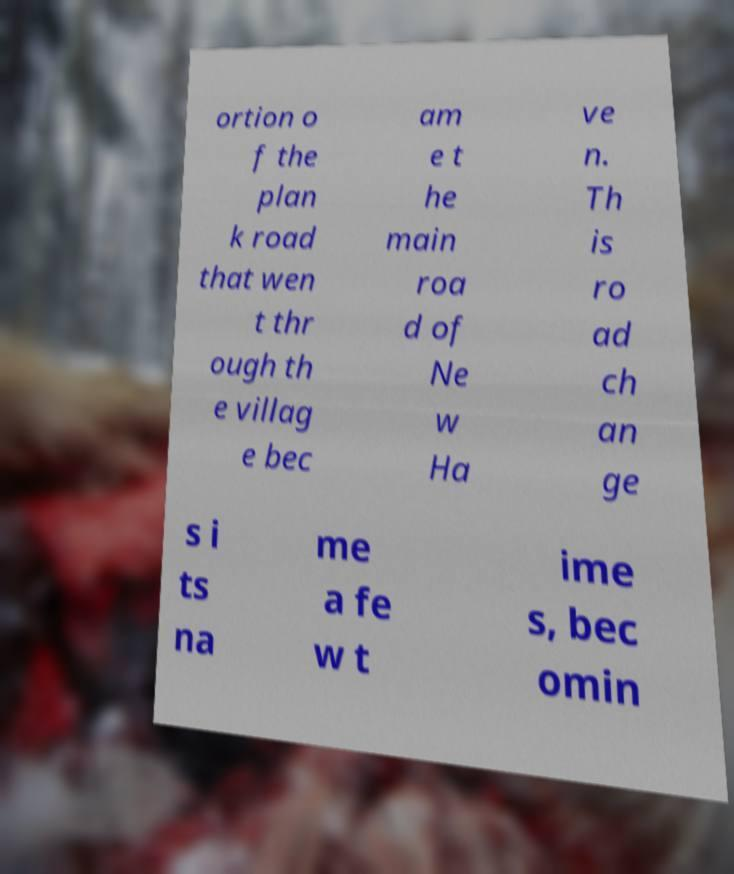I need the written content from this picture converted into text. Can you do that? ortion o f the plan k road that wen t thr ough th e villag e bec am e t he main roa d of Ne w Ha ve n. Th is ro ad ch an ge s i ts na me a fe w t ime s, bec omin 